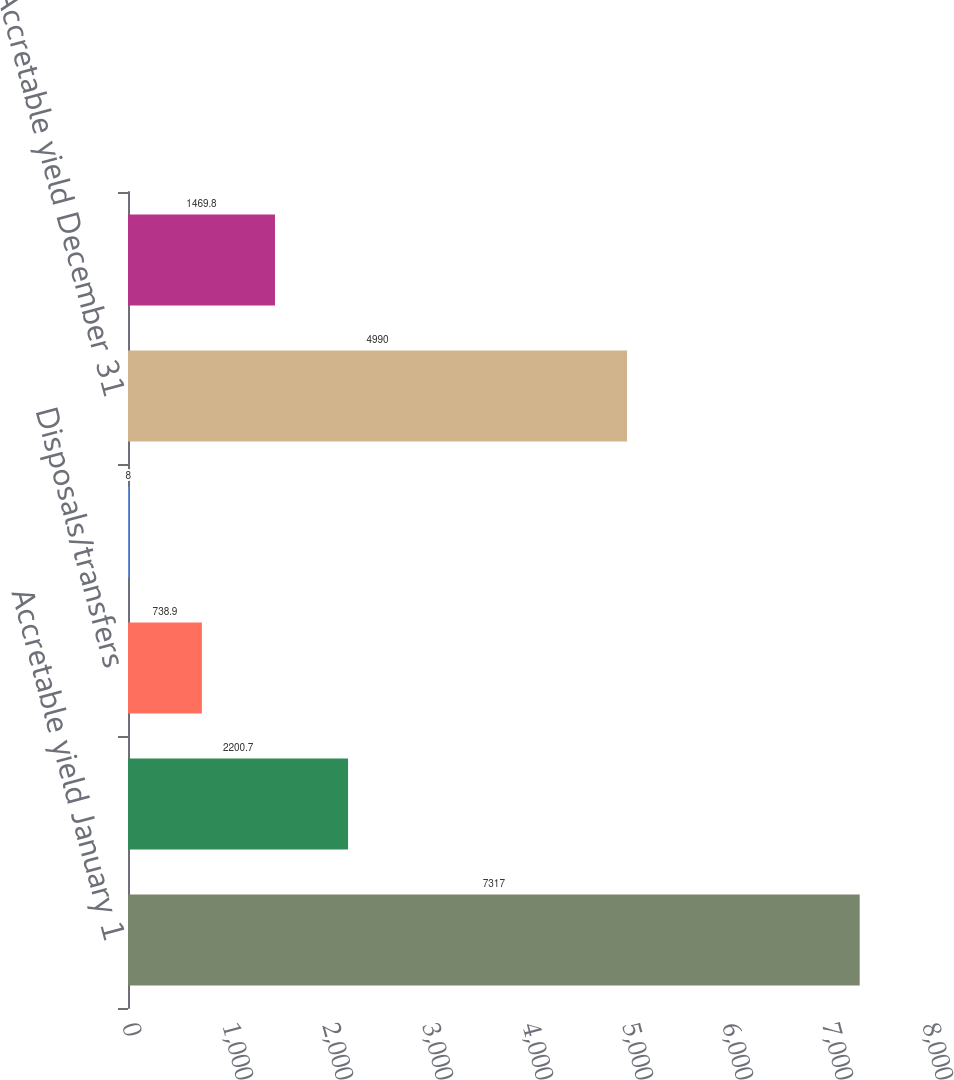Convert chart. <chart><loc_0><loc_0><loc_500><loc_500><bar_chart><fcel>Accretable yield January 1<fcel>Accretion<fcel>Disposals/transfers<fcel>Reclassifications to<fcel>Accretable yield December 31<fcel>Reclassifications from<nl><fcel>7317<fcel>2200.7<fcel>738.9<fcel>8<fcel>4990<fcel>1469.8<nl></chart> 